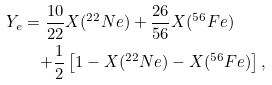<formula> <loc_0><loc_0><loc_500><loc_500>Y _ { e } = \frac { 1 0 } { 2 2 } & X ( ^ { 2 2 } N e ) + \frac { 2 6 } { 5 6 } X ( ^ { 5 6 } F e ) \\ + \frac { 1 } { 2 } & \left [ 1 - X ( ^ { 2 2 } N e ) - X ( ^ { 5 6 } F e ) \right ] ,</formula> 